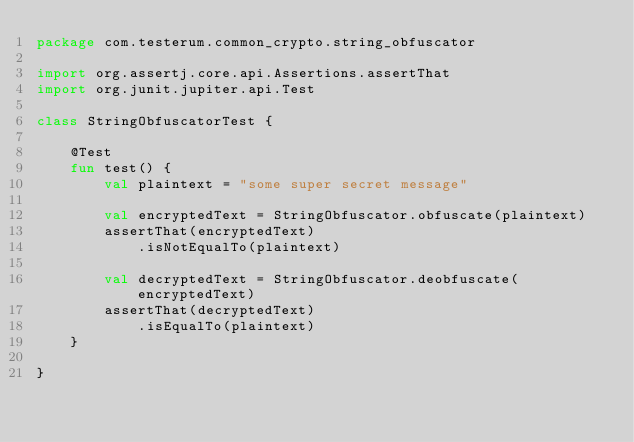<code> <loc_0><loc_0><loc_500><loc_500><_Kotlin_>package com.testerum.common_crypto.string_obfuscator

import org.assertj.core.api.Assertions.assertThat
import org.junit.jupiter.api.Test

class StringObfuscatorTest {

    @Test
    fun test() {
        val plaintext = "some super secret message"

        val encryptedText = StringObfuscator.obfuscate(plaintext)
        assertThat(encryptedText)
            .isNotEqualTo(plaintext)

        val decryptedText = StringObfuscator.deobfuscate(encryptedText)
        assertThat(decryptedText)
            .isEqualTo(plaintext)
    }

}
</code> 